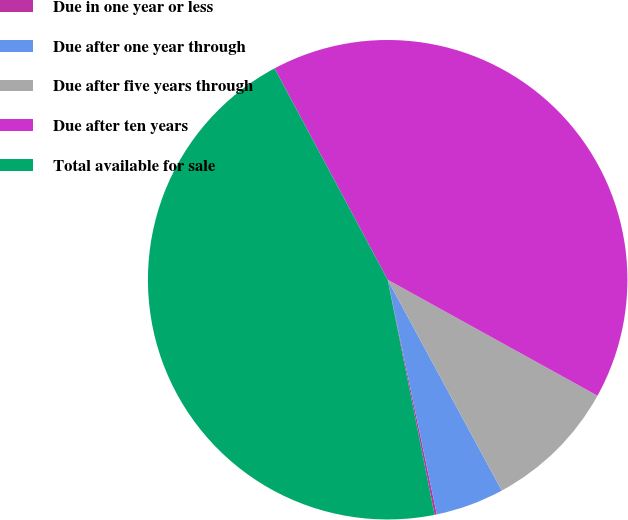<chart> <loc_0><loc_0><loc_500><loc_500><pie_chart><fcel>Due in one year or less<fcel>Due after one year through<fcel>Due after five years through<fcel>Due after ten years<fcel>Total available for sale<nl><fcel>0.15%<fcel>4.61%<fcel>9.07%<fcel>40.86%<fcel>45.32%<nl></chart> 